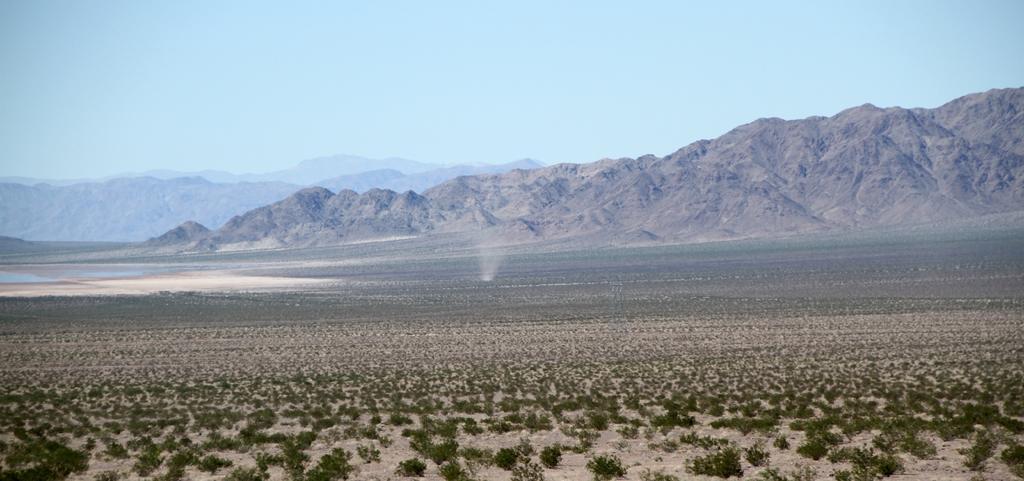Can you describe this image briefly? In this picture we can see planets on the ground, mountains and in the background we can see the sky. 